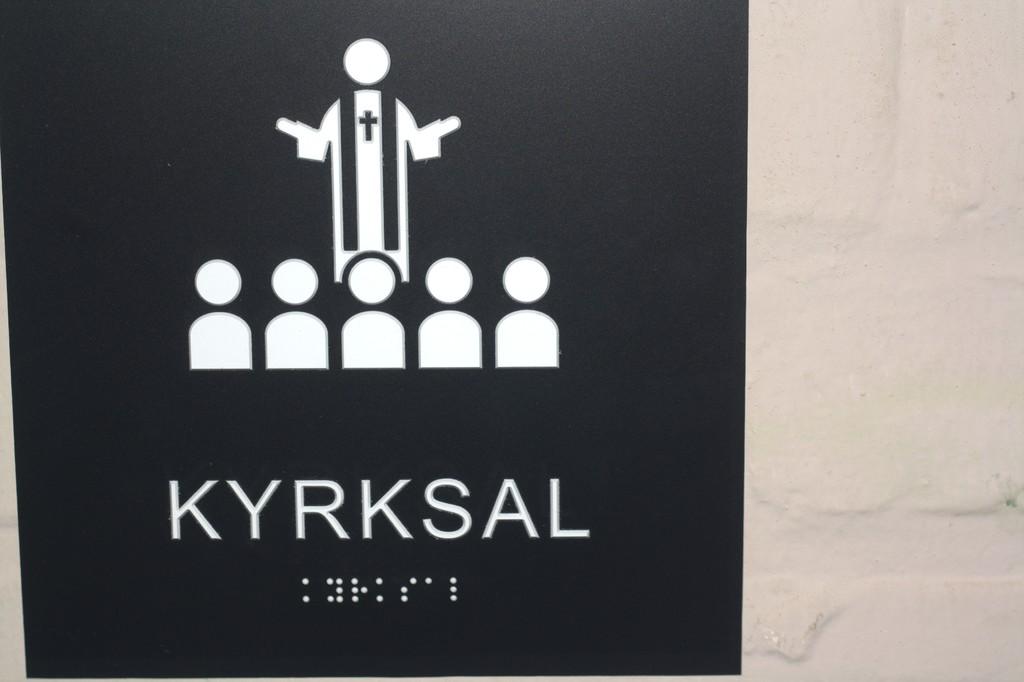What is the name of the publication?
Offer a terse response. Kyrksal. 